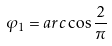<formula> <loc_0><loc_0><loc_500><loc_500>\varphi _ { 1 } = a r c \cos \frac { 2 } { \pi }</formula> 